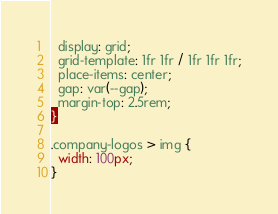Convert code to text. <code><loc_0><loc_0><loc_500><loc_500><_CSS_>  display: grid;
  grid-template: 1fr 1fr / 1fr 1fr 1fr;
  place-items: center;
  gap: var(--gap);
  margin-top: 2.5rem;
}

.company-logos > img {
  width: 100px;
}
</code> 